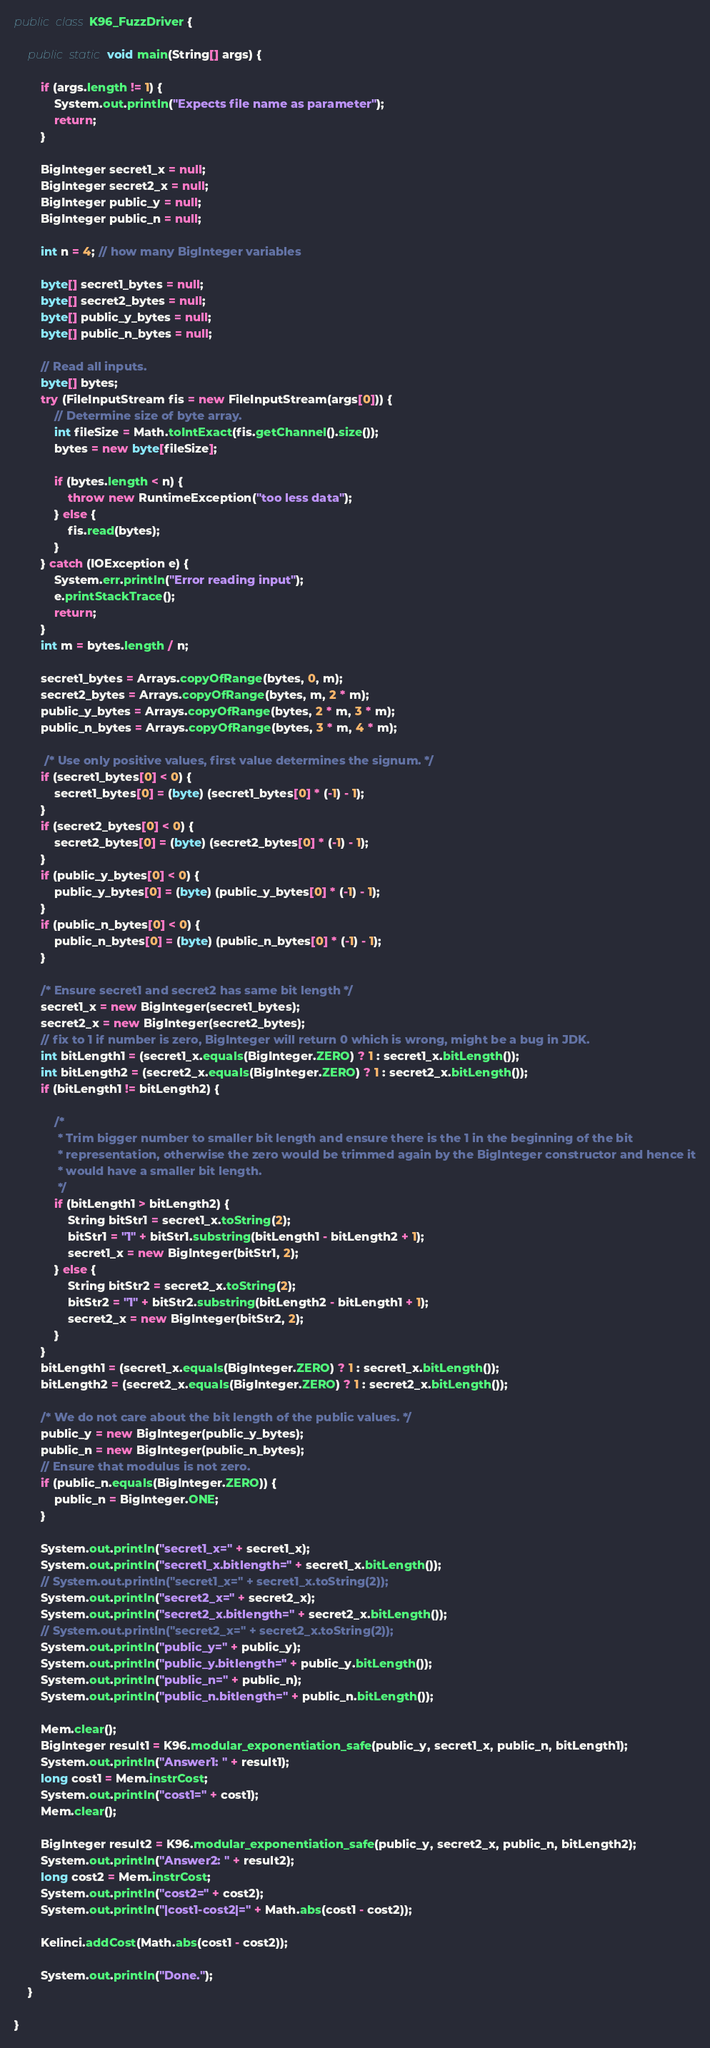Convert code to text. <code><loc_0><loc_0><loc_500><loc_500><_Java_>public class K96_FuzzDriver {

    public static void main(String[] args) {

        if (args.length != 1) {
            System.out.println("Expects file name as parameter");
            return;
        }

        BigInteger secret1_x = null;
        BigInteger secret2_x = null;
        BigInteger public_y = null;
        BigInteger public_n = null;

        int n = 4; // how many BigInteger variables

        byte[] secret1_bytes = null;
        byte[] secret2_bytes = null;
        byte[] public_y_bytes = null;
        byte[] public_n_bytes = null;

        // Read all inputs.
        byte[] bytes;
        try (FileInputStream fis = new FileInputStream(args[0])) {
            // Determine size of byte array.
            int fileSize = Math.toIntExact(fis.getChannel().size());
            bytes = new byte[fileSize];

            if (bytes.length < n) {
                throw new RuntimeException("too less data");
            } else {
                fis.read(bytes);
            }
        } catch (IOException e) {
            System.err.println("Error reading input");
            e.printStackTrace();
            return;
        }
        int m = bytes.length / n;

        secret1_bytes = Arrays.copyOfRange(bytes, 0, m);
        secret2_bytes = Arrays.copyOfRange(bytes, m, 2 * m);
        public_y_bytes = Arrays.copyOfRange(bytes, 2 * m, 3 * m);
        public_n_bytes = Arrays.copyOfRange(bytes, 3 * m, 4 * m);

         /* Use only positive values, first value determines the signum. */
        if (secret1_bytes[0] < 0) {
            secret1_bytes[0] = (byte) (secret1_bytes[0] * (-1) - 1);
        }
        if (secret2_bytes[0] < 0) {
            secret2_bytes[0] = (byte) (secret2_bytes[0] * (-1) - 1);
        }
        if (public_y_bytes[0] < 0) {
            public_y_bytes[0] = (byte) (public_y_bytes[0] * (-1) - 1);
        }
        if (public_n_bytes[0] < 0) {
            public_n_bytes[0] = (byte) (public_n_bytes[0] * (-1) - 1);
        }

        /* Ensure secret1 and secret2 has same bit length */
        secret1_x = new BigInteger(secret1_bytes);
        secret2_x = new BigInteger(secret2_bytes);
        // fix to 1 if number is zero, BigInteger will return 0 which is wrong, might be a bug in JDK.
        int bitLength1 = (secret1_x.equals(BigInteger.ZERO) ? 1 : secret1_x.bitLength());
        int bitLength2 = (secret2_x.equals(BigInteger.ZERO) ? 1 : secret2_x.bitLength());
        if (bitLength1 != bitLength2) {

            /*
             * Trim bigger number to smaller bit length and ensure there is the 1 in the beginning of the bit
             * representation, otherwise the zero would be trimmed again by the BigInteger constructor and hence it
             * would have a smaller bit length.
             */
            if (bitLength1 > bitLength2) {
                String bitStr1 = secret1_x.toString(2);
                bitStr1 = "1" + bitStr1.substring(bitLength1 - bitLength2 + 1);
                secret1_x = new BigInteger(bitStr1, 2);
            } else {
                String bitStr2 = secret2_x.toString(2);
                bitStr2 = "1" + bitStr2.substring(bitLength2 - bitLength1 + 1);
                secret2_x = new BigInteger(bitStr2, 2);
            }
        }
        bitLength1 = (secret1_x.equals(BigInteger.ZERO) ? 1 : secret1_x.bitLength());
        bitLength2 = (secret2_x.equals(BigInteger.ZERO) ? 1 : secret2_x.bitLength());

        /* We do not care about the bit length of the public values. */
        public_y = new BigInteger(public_y_bytes);
        public_n = new BigInteger(public_n_bytes);
        // Ensure that modulus is not zero.
        if (public_n.equals(BigInteger.ZERO)) {
            public_n = BigInteger.ONE;
        }

        System.out.println("secret1_x=" + secret1_x);
        System.out.println("secret1_x.bitlength=" + secret1_x.bitLength());
        // System.out.println("secret1_x=" + secret1_x.toString(2));
        System.out.println("secret2_x=" + secret2_x);
        System.out.println("secret2_x.bitlength=" + secret2_x.bitLength());
        // System.out.println("secret2_x=" + secret2_x.toString(2));
        System.out.println("public_y=" + public_y);
        System.out.println("public_y.bitlength=" + public_y.bitLength());
        System.out.println("public_n=" + public_n);
        System.out.println("public_n.bitlength=" + public_n.bitLength());

        Mem.clear();
        BigInteger result1 = K96.modular_exponentiation_safe(public_y, secret1_x, public_n, bitLength1);
        System.out.println("Answer1: " + result1);
        long cost1 = Mem.instrCost;
        System.out.println("cost1=" + cost1);
        Mem.clear();
      
        BigInteger result2 = K96.modular_exponentiation_safe(public_y, secret2_x, public_n, bitLength2);
        System.out.println("Answer2: " + result2);
        long cost2 = Mem.instrCost;
        System.out.println("cost2=" + cost2);
        System.out.println("|cost1-cost2|=" + Math.abs(cost1 - cost2));
        
        Kelinci.addCost(Math.abs(cost1 - cost2));

        System.out.println("Done.");
    }

}
</code> 